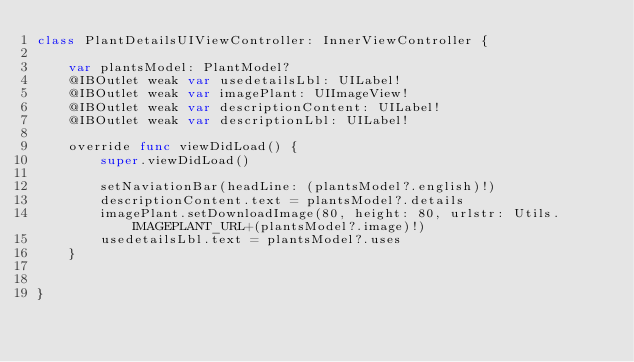<code> <loc_0><loc_0><loc_500><loc_500><_Swift_>class PlantDetailsUIViewController: InnerViewController {
    
    var plantsModel: PlantModel?    
    @IBOutlet weak var usedetailsLbl: UILabel!
    @IBOutlet weak var imagePlant: UIImageView!
    @IBOutlet weak var descriptionContent: UILabel!
    @IBOutlet weak var descriptionLbl: UILabel!
    
    override func viewDidLoad() {
        super.viewDidLoad()
        
        setNaviationBar(headLine: (plantsModel?.english)!)
        descriptionContent.text = plantsModel?.details
        imagePlant.setDownloadImage(80, height: 80, urlstr: Utils.IMAGEPLANT_URL+(plantsModel?.image)!)
        usedetailsLbl.text = plantsModel?.uses
    }
    
    
}
</code> 